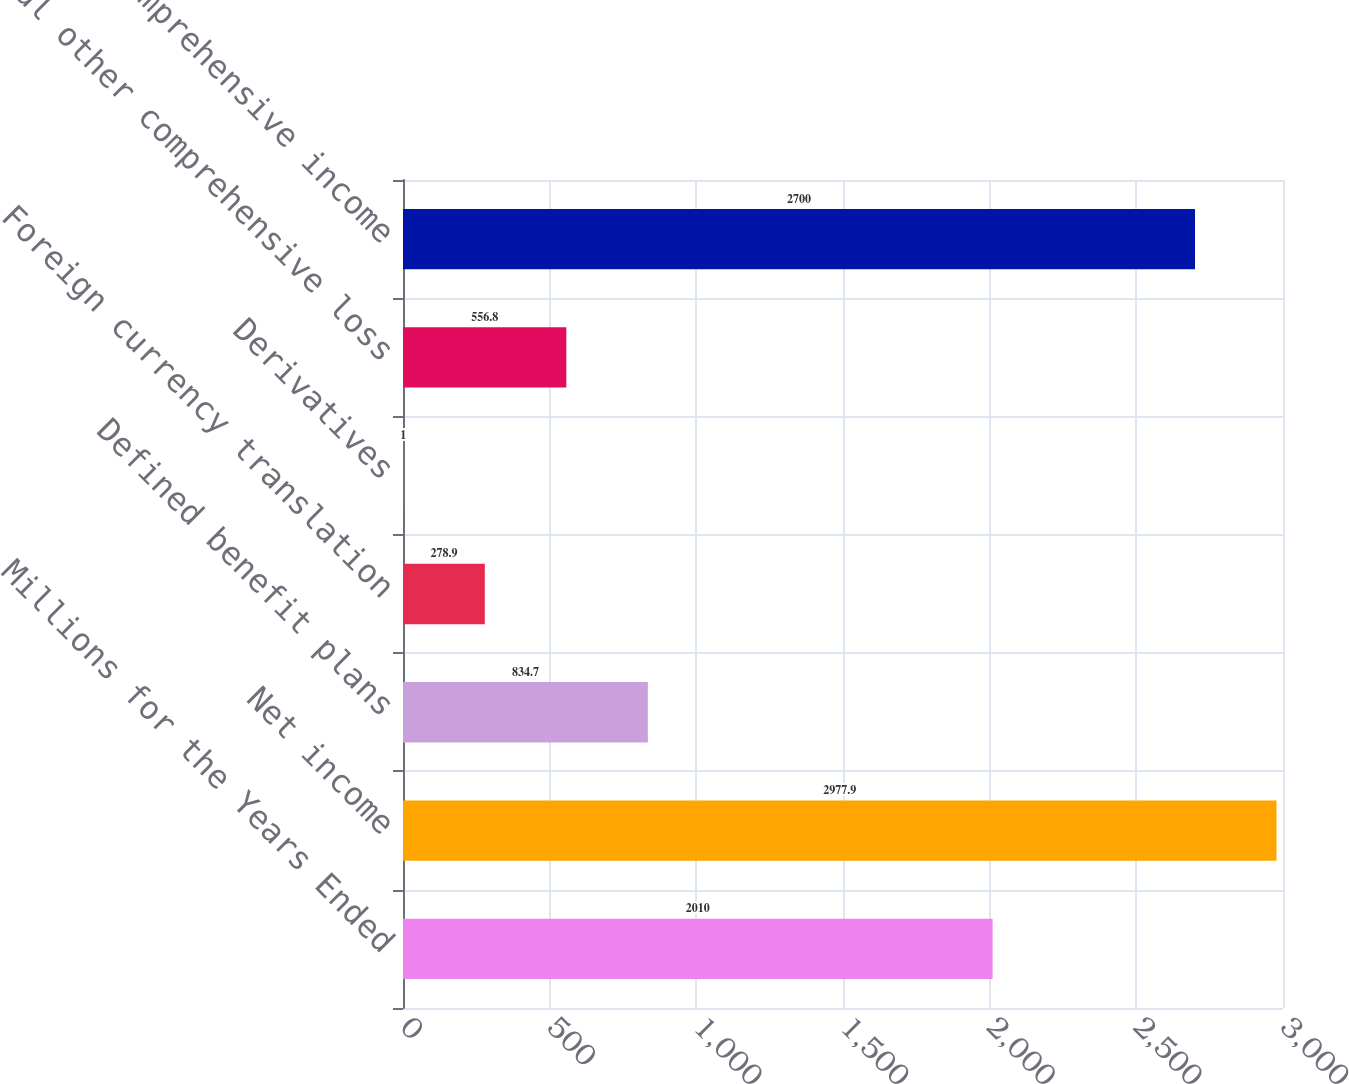Convert chart. <chart><loc_0><loc_0><loc_500><loc_500><bar_chart><fcel>Millions for the Years Ended<fcel>Net income<fcel>Defined benefit plans<fcel>Foreign currency translation<fcel>Derivatives<fcel>Total other comprehensive loss<fcel>Comprehensive income<nl><fcel>2010<fcel>2977.9<fcel>834.7<fcel>278.9<fcel>1<fcel>556.8<fcel>2700<nl></chart> 